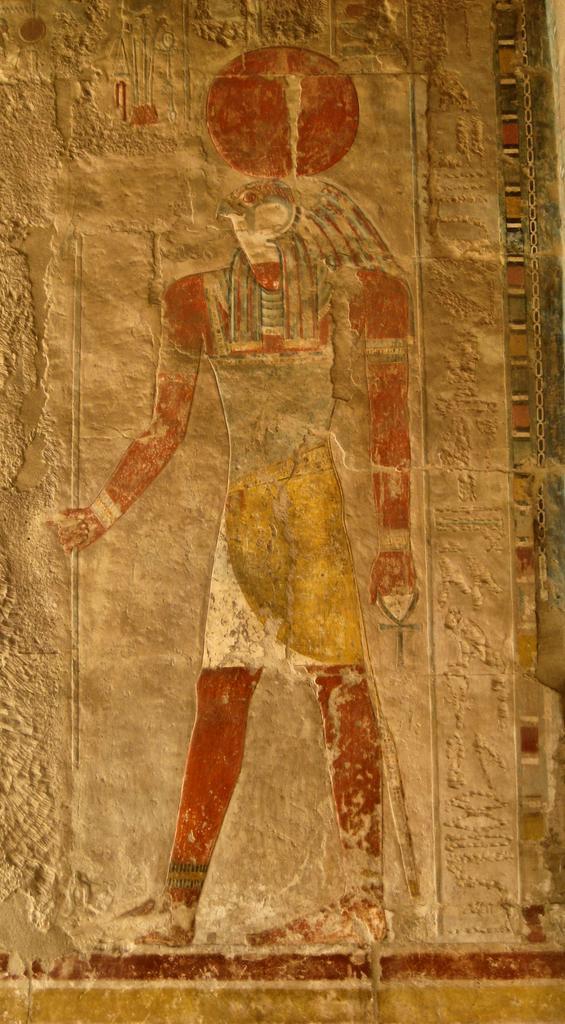Can you describe this image briefly? In the image in the center, we can see one Horus artwork on the wall. 